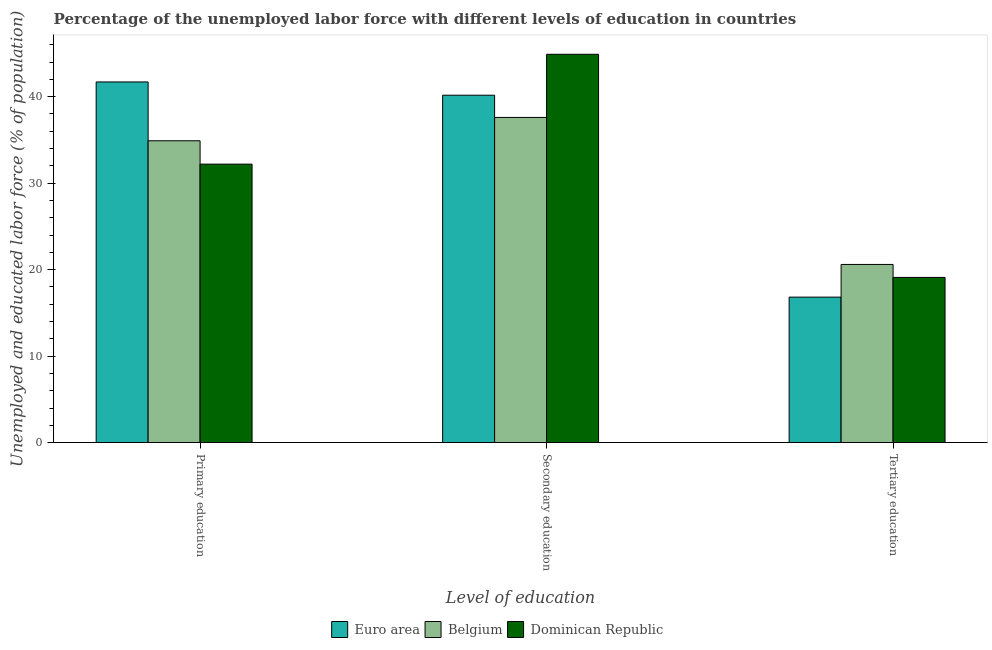How many groups of bars are there?
Your answer should be compact. 3. How many bars are there on the 1st tick from the left?
Your answer should be very brief. 3. How many bars are there on the 1st tick from the right?
Make the answer very short. 3. What is the label of the 1st group of bars from the left?
Your answer should be very brief. Primary education. What is the percentage of labor force who received tertiary education in Belgium?
Your response must be concise. 20.6. Across all countries, what is the maximum percentage of labor force who received tertiary education?
Offer a terse response. 20.6. Across all countries, what is the minimum percentage of labor force who received secondary education?
Provide a short and direct response. 37.6. In which country was the percentage of labor force who received tertiary education maximum?
Your answer should be very brief. Belgium. In which country was the percentage of labor force who received primary education minimum?
Keep it short and to the point. Dominican Republic. What is the total percentage of labor force who received secondary education in the graph?
Your answer should be very brief. 122.67. What is the difference between the percentage of labor force who received secondary education in Euro area and that in Belgium?
Provide a succinct answer. 2.57. What is the difference between the percentage of labor force who received primary education in Dominican Republic and the percentage of labor force who received tertiary education in Euro area?
Your answer should be compact. 15.38. What is the average percentage of labor force who received tertiary education per country?
Provide a short and direct response. 18.84. What is the difference between the percentage of labor force who received secondary education and percentage of labor force who received primary education in Euro area?
Your response must be concise. -1.53. In how many countries, is the percentage of labor force who received secondary education greater than 20 %?
Make the answer very short. 3. What is the ratio of the percentage of labor force who received secondary education in Belgium to that in Euro area?
Your response must be concise. 0.94. Is the percentage of labor force who received tertiary education in Dominican Republic less than that in Euro area?
Keep it short and to the point. No. Is the difference between the percentage of labor force who received primary education in Dominican Republic and Euro area greater than the difference between the percentage of labor force who received secondary education in Dominican Republic and Euro area?
Make the answer very short. No. What is the difference between the highest and the lowest percentage of labor force who received primary education?
Ensure brevity in your answer.  9.5. Is the sum of the percentage of labor force who received secondary education in Belgium and Euro area greater than the maximum percentage of labor force who received primary education across all countries?
Your answer should be very brief. Yes. What does the 3rd bar from the left in Secondary education represents?
Your answer should be very brief. Dominican Republic. What does the 3rd bar from the right in Primary education represents?
Offer a terse response. Euro area. Is it the case that in every country, the sum of the percentage of labor force who received primary education and percentage of labor force who received secondary education is greater than the percentage of labor force who received tertiary education?
Your response must be concise. Yes. How many countries are there in the graph?
Give a very brief answer. 3. Are the values on the major ticks of Y-axis written in scientific E-notation?
Keep it short and to the point. No. Does the graph contain grids?
Provide a short and direct response. No. Where does the legend appear in the graph?
Provide a succinct answer. Bottom center. How many legend labels are there?
Ensure brevity in your answer.  3. What is the title of the graph?
Give a very brief answer. Percentage of the unemployed labor force with different levels of education in countries. What is the label or title of the X-axis?
Your response must be concise. Level of education. What is the label or title of the Y-axis?
Keep it short and to the point. Unemployed and educated labor force (% of population). What is the Unemployed and educated labor force (% of population) in Euro area in Primary education?
Make the answer very short. 41.7. What is the Unemployed and educated labor force (% of population) of Belgium in Primary education?
Your response must be concise. 34.9. What is the Unemployed and educated labor force (% of population) of Dominican Republic in Primary education?
Provide a short and direct response. 32.2. What is the Unemployed and educated labor force (% of population) in Euro area in Secondary education?
Your answer should be compact. 40.17. What is the Unemployed and educated labor force (% of population) in Belgium in Secondary education?
Your response must be concise. 37.6. What is the Unemployed and educated labor force (% of population) of Dominican Republic in Secondary education?
Your answer should be very brief. 44.9. What is the Unemployed and educated labor force (% of population) in Euro area in Tertiary education?
Your answer should be very brief. 16.82. What is the Unemployed and educated labor force (% of population) in Belgium in Tertiary education?
Give a very brief answer. 20.6. What is the Unemployed and educated labor force (% of population) in Dominican Republic in Tertiary education?
Give a very brief answer. 19.1. Across all Level of education, what is the maximum Unemployed and educated labor force (% of population) of Euro area?
Provide a short and direct response. 41.7. Across all Level of education, what is the maximum Unemployed and educated labor force (% of population) in Belgium?
Your response must be concise. 37.6. Across all Level of education, what is the maximum Unemployed and educated labor force (% of population) in Dominican Republic?
Keep it short and to the point. 44.9. Across all Level of education, what is the minimum Unemployed and educated labor force (% of population) of Euro area?
Provide a succinct answer. 16.82. Across all Level of education, what is the minimum Unemployed and educated labor force (% of population) in Belgium?
Provide a succinct answer. 20.6. Across all Level of education, what is the minimum Unemployed and educated labor force (% of population) in Dominican Republic?
Ensure brevity in your answer.  19.1. What is the total Unemployed and educated labor force (% of population) of Euro area in the graph?
Make the answer very short. 98.69. What is the total Unemployed and educated labor force (% of population) in Belgium in the graph?
Your answer should be compact. 93.1. What is the total Unemployed and educated labor force (% of population) in Dominican Republic in the graph?
Make the answer very short. 96.2. What is the difference between the Unemployed and educated labor force (% of population) in Euro area in Primary education and that in Secondary education?
Keep it short and to the point. 1.53. What is the difference between the Unemployed and educated labor force (% of population) of Belgium in Primary education and that in Secondary education?
Give a very brief answer. -2.7. What is the difference between the Unemployed and educated labor force (% of population) of Dominican Republic in Primary education and that in Secondary education?
Your response must be concise. -12.7. What is the difference between the Unemployed and educated labor force (% of population) of Euro area in Primary education and that in Tertiary education?
Provide a succinct answer. 24.88. What is the difference between the Unemployed and educated labor force (% of population) in Euro area in Secondary education and that in Tertiary education?
Offer a terse response. 23.35. What is the difference between the Unemployed and educated labor force (% of population) of Dominican Republic in Secondary education and that in Tertiary education?
Make the answer very short. 25.8. What is the difference between the Unemployed and educated labor force (% of population) of Euro area in Primary education and the Unemployed and educated labor force (% of population) of Belgium in Secondary education?
Offer a terse response. 4.1. What is the difference between the Unemployed and educated labor force (% of population) of Euro area in Primary education and the Unemployed and educated labor force (% of population) of Dominican Republic in Secondary education?
Provide a succinct answer. -3.2. What is the difference between the Unemployed and educated labor force (% of population) of Euro area in Primary education and the Unemployed and educated labor force (% of population) of Belgium in Tertiary education?
Make the answer very short. 21.1. What is the difference between the Unemployed and educated labor force (% of population) of Euro area in Primary education and the Unemployed and educated labor force (% of population) of Dominican Republic in Tertiary education?
Offer a terse response. 22.6. What is the difference between the Unemployed and educated labor force (% of population) of Belgium in Primary education and the Unemployed and educated labor force (% of population) of Dominican Republic in Tertiary education?
Provide a short and direct response. 15.8. What is the difference between the Unemployed and educated labor force (% of population) of Euro area in Secondary education and the Unemployed and educated labor force (% of population) of Belgium in Tertiary education?
Give a very brief answer. 19.57. What is the difference between the Unemployed and educated labor force (% of population) of Euro area in Secondary education and the Unemployed and educated labor force (% of population) of Dominican Republic in Tertiary education?
Offer a terse response. 21.07. What is the difference between the Unemployed and educated labor force (% of population) in Belgium in Secondary education and the Unemployed and educated labor force (% of population) in Dominican Republic in Tertiary education?
Ensure brevity in your answer.  18.5. What is the average Unemployed and educated labor force (% of population) of Euro area per Level of education?
Your answer should be compact. 32.9. What is the average Unemployed and educated labor force (% of population) in Belgium per Level of education?
Offer a very short reply. 31.03. What is the average Unemployed and educated labor force (% of population) in Dominican Republic per Level of education?
Provide a short and direct response. 32.07. What is the difference between the Unemployed and educated labor force (% of population) in Euro area and Unemployed and educated labor force (% of population) in Belgium in Primary education?
Keep it short and to the point. 6.8. What is the difference between the Unemployed and educated labor force (% of population) of Euro area and Unemployed and educated labor force (% of population) of Dominican Republic in Primary education?
Your response must be concise. 9.5. What is the difference between the Unemployed and educated labor force (% of population) in Belgium and Unemployed and educated labor force (% of population) in Dominican Republic in Primary education?
Your response must be concise. 2.7. What is the difference between the Unemployed and educated labor force (% of population) in Euro area and Unemployed and educated labor force (% of population) in Belgium in Secondary education?
Your answer should be very brief. 2.57. What is the difference between the Unemployed and educated labor force (% of population) in Euro area and Unemployed and educated labor force (% of population) in Dominican Republic in Secondary education?
Provide a short and direct response. -4.73. What is the difference between the Unemployed and educated labor force (% of population) in Belgium and Unemployed and educated labor force (% of population) in Dominican Republic in Secondary education?
Provide a succinct answer. -7.3. What is the difference between the Unemployed and educated labor force (% of population) in Euro area and Unemployed and educated labor force (% of population) in Belgium in Tertiary education?
Your response must be concise. -3.78. What is the difference between the Unemployed and educated labor force (% of population) of Euro area and Unemployed and educated labor force (% of population) of Dominican Republic in Tertiary education?
Keep it short and to the point. -2.28. What is the ratio of the Unemployed and educated labor force (% of population) in Euro area in Primary education to that in Secondary education?
Provide a succinct answer. 1.04. What is the ratio of the Unemployed and educated labor force (% of population) in Belgium in Primary education to that in Secondary education?
Keep it short and to the point. 0.93. What is the ratio of the Unemployed and educated labor force (% of population) in Dominican Republic in Primary education to that in Secondary education?
Provide a short and direct response. 0.72. What is the ratio of the Unemployed and educated labor force (% of population) of Euro area in Primary education to that in Tertiary education?
Give a very brief answer. 2.48. What is the ratio of the Unemployed and educated labor force (% of population) of Belgium in Primary education to that in Tertiary education?
Provide a short and direct response. 1.69. What is the ratio of the Unemployed and educated labor force (% of population) in Dominican Republic in Primary education to that in Tertiary education?
Your answer should be compact. 1.69. What is the ratio of the Unemployed and educated labor force (% of population) of Euro area in Secondary education to that in Tertiary education?
Offer a terse response. 2.39. What is the ratio of the Unemployed and educated labor force (% of population) in Belgium in Secondary education to that in Tertiary education?
Ensure brevity in your answer.  1.83. What is the ratio of the Unemployed and educated labor force (% of population) of Dominican Republic in Secondary education to that in Tertiary education?
Your answer should be very brief. 2.35. What is the difference between the highest and the second highest Unemployed and educated labor force (% of population) in Euro area?
Provide a succinct answer. 1.53. What is the difference between the highest and the lowest Unemployed and educated labor force (% of population) in Euro area?
Provide a succinct answer. 24.88. What is the difference between the highest and the lowest Unemployed and educated labor force (% of population) of Dominican Republic?
Provide a succinct answer. 25.8. 